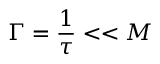<formula> <loc_0><loc_0><loc_500><loc_500>\Gamma = { \frac { 1 } { \tau } } < < M</formula> 